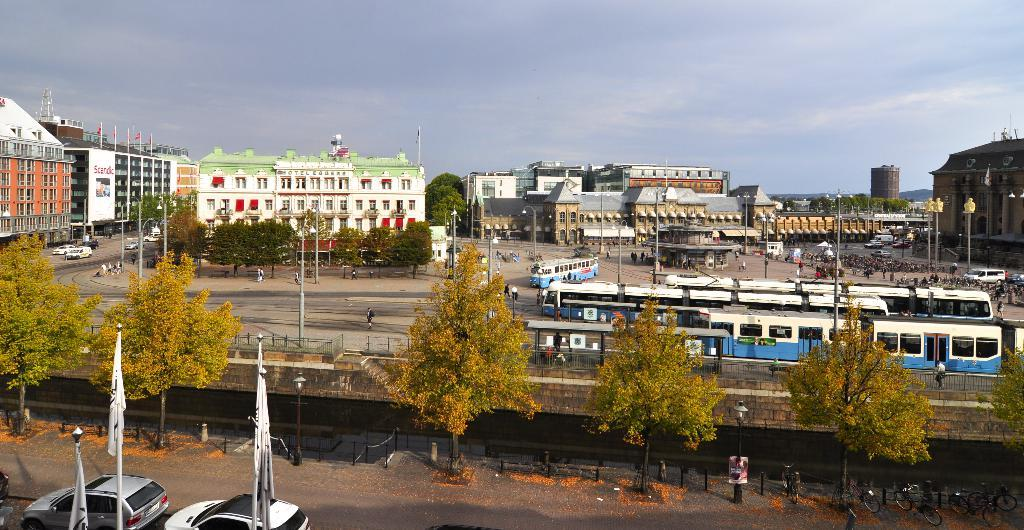What objects with poles can be seen in the image? There are flags with poles in the image. What types of transportation are visible in the image? Cars and bicycles are visible in the image. What type of natural element is present in the image? There are trees in the image. What type of barrier can be seen in the image? There is a fence in the image. What can be seen in the background of the image? In the background of the image, there are people, vehicles, trees, and buildings, as well as the sky. Can you tell me how many slaves are depicted in the image? There are no slaves depicted in the image; the provided facts do not mention any such subject. What type of line is present in the image? There is no specific line mentioned in the image; the provided facts focus on objects and elements like flags, cars, bicycles, trees, fences, people, vehicles, and buildings. 